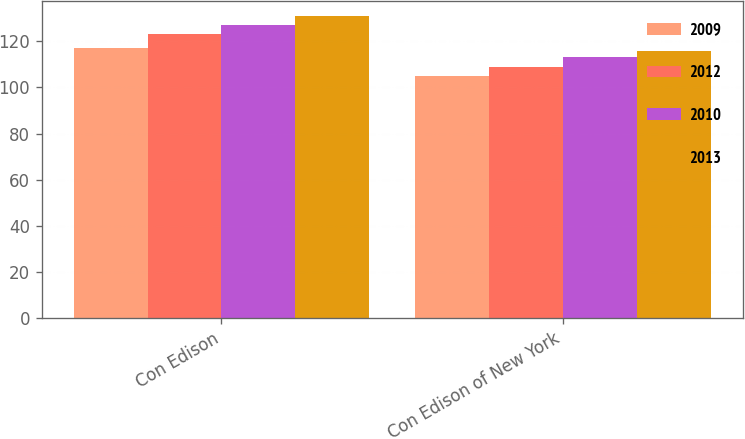Convert chart. <chart><loc_0><loc_0><loc_500><loc_500><stacked_bar_chart><ecel><fcel>Con Edison<fcel>Con Edison of New York<nl><fcel>2009<fcel>117<fcel>105<nl><fcel>2012<fcel>123<fcel>109<nl><fcel>2010<fcel>127<fcel>113<nl><fcel>2013<fcel>131<fcel>116<nl></chart> 